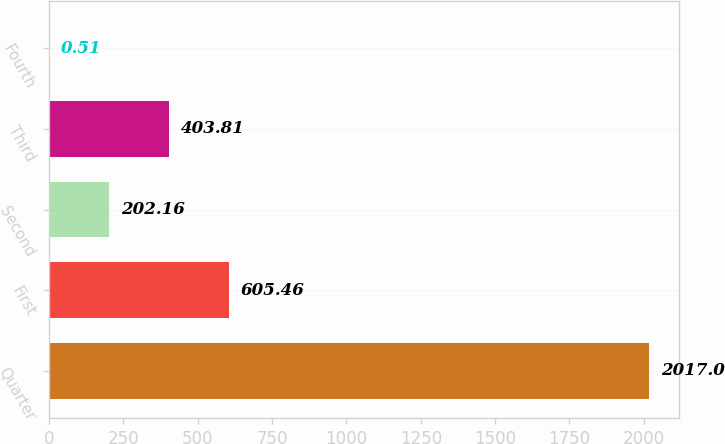Convert chart to OTSL. <chart><loc_0><loc_0><loc_500><loc_500><bar_chart><fcel>Quarter<fcel>First<fcel>Second<fcel>Third<fcel>Fourth<nl><fcel>2017<fcel>605.46<fcel>202.16<fcel>403.81<fcel>0.51<nl></chart> 